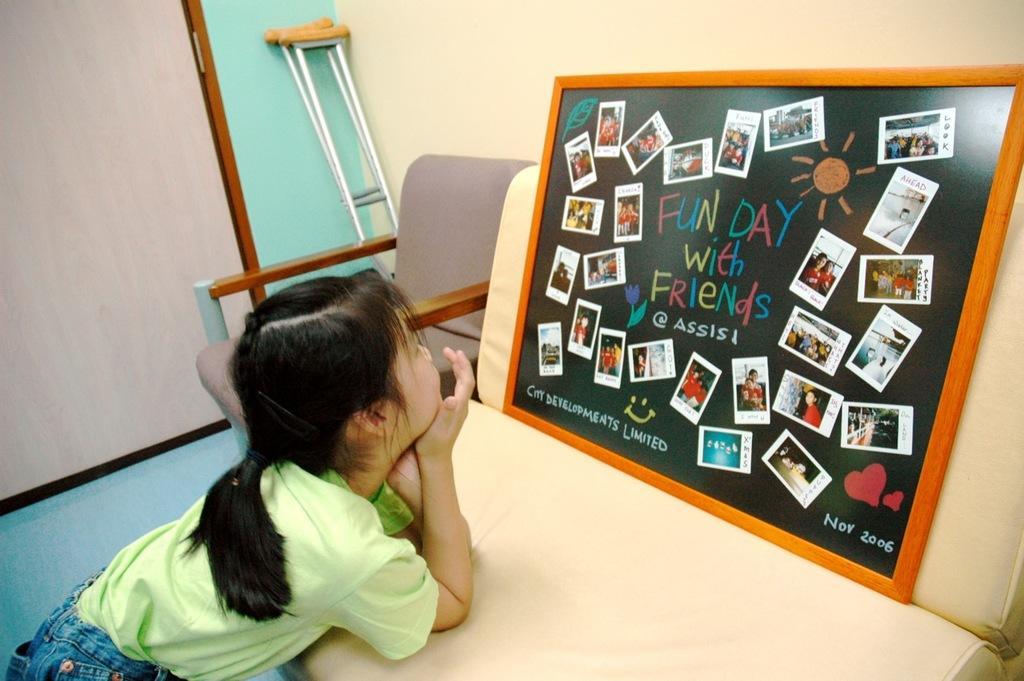In one or two sentences, can you explain what this image depicts? In the picture we can find a girl leaning on the chair and watching the board collage. In the background we can find one chair, stands, door and a wall. The girl is wearing green T-shirt. 